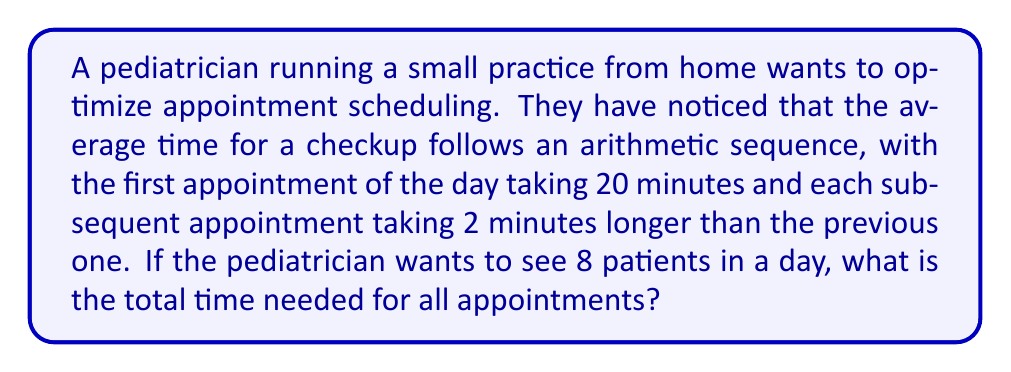Help me with this question. Let's approach this step-by-step using the arithmetic sequence formula:

1) In an arithmetic sequence, the nth term is given by:
   $a_n = a_1 + (n-1)d$
   Where $a_1$ is the first term, n is the position, and d is the common difference.

2) We know:
   $a_1 = 20$ minutes (first appointment)
   $d = 2$ minutes (each appointment takes 2 minutes longer)
   $n = 8$ (total number of appointments)

3) The last appointment (8th) will take:
   $a_8 = 20 + (8-1)2 = 20 + 14 = 34$ minutes

4) To find the total time, we need the sum of this arithmetic sequence. The formula for the sum of an arithmetic sequence is:
   $S_n = \frac{n}{2}(a_1 + a_n)$

5) Substituting our values:
   $S_8 = \frac{8}{2}(20 + 34) = 4(54) = 216$

Therefore, the total time needed for all 8 appointments is 216 minutes.
Answer: 216 minutes 